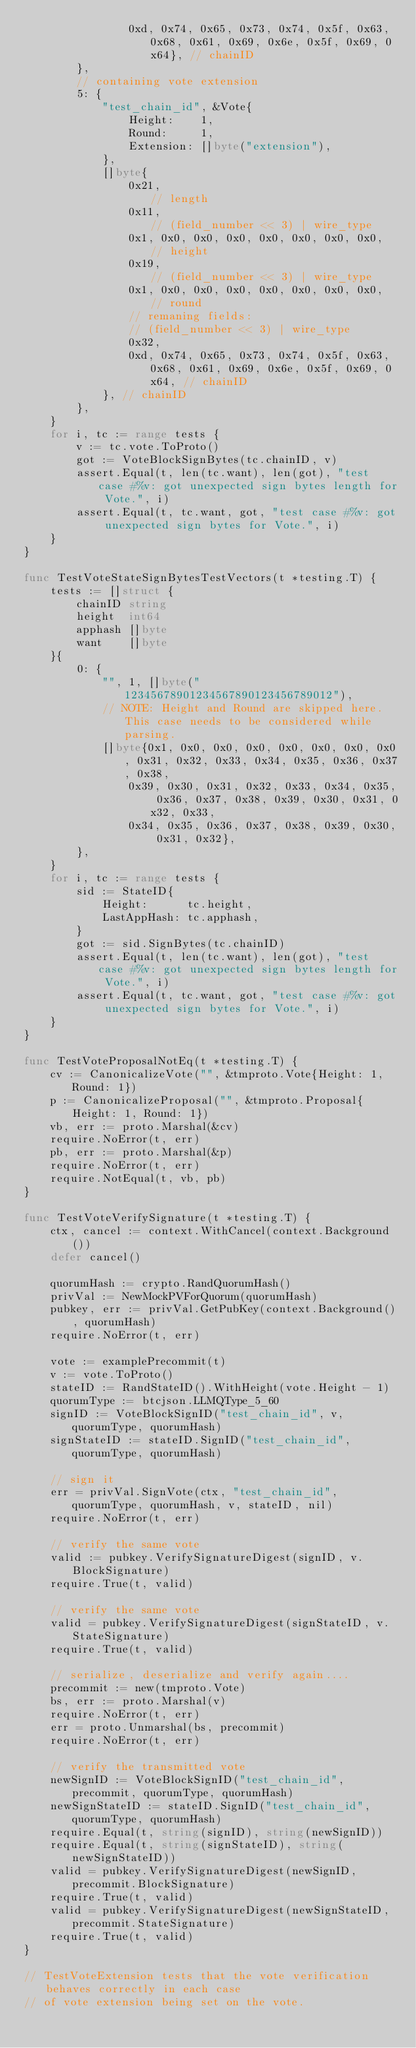<code> <loc_0><loc_0><loc_500><loc_500><_Go_>				0xd, 0x74, 0x65, 0x73, 0x74, 0x5f, 0x63, 0x68, 0x61, 0x69, 0x6e, 0x5f, 0x69, 0x64}, // chainID
		},
		// containing vote extension
		5: {
			"test_chain_id", &Vote{
				Height:    1,
				Round:     1,
				Extension: []byte("extension"),
			},
			[]byte{
				0x21,                                   // length
				0x11,                                   // (field_number << 3) | wire_type
				0x1, 0x0, 0x0, 0x0, 0x0, 0x0, 0x0, 0x0, // height
				0x19,                                   // (field_number << 3) | wire_type
				0x1, 0x0, 0x0, 0x0, 0x0, 0x0, 0x0, 0x0, // round
				// remaning fields:
				// (field_number << 3) | wire_type
				0x32,
				0xd, 0x74, 0x65, 0x73, 0x74, 0x5f, 0x63, 0x68, 0x61, 0x69, 0x6e, 0x5f, 0x69, 0x64, // chainID
			}, // chainID
		},
	}
	for i, tc := range tests {
		v := tc.vote.ToProto()
		got := VoteBlockSignBytes(tc.chainID, v)
		assert.Equal(t, len(tc.want), len(got), "test case #%v: got unexpected sign bytes length for Vote.", i)
		assert.Equal(t, tc.want, got, "test case #%v: got unexpected sign bytes for Vote.", i)
	}
}

func TestVoteStateSignBytesTestVectors(t *testing.T) {
	tests := []struct {
		chainID string
		height  int64
		apphash []byte
		want    []byte
	}{
		0: {
			"", 1, []byte("12345678901234567890123456789012"),
			// NOTE: Height and Round are skipped here. This case needs to be considered while parsing.
			[]byte{0x1, 0x0, 0x0, 0x0, 0x0, 0x0, 0x0, 0x0, 0x31, 0x32, 0x33, 0x34, 0x35, 0x36, 0x37, 0x38,
				0x39, 0x30, 0x31, 0x32, 0x33, 0x34, 0x35, 0x36, 0x37, 0x38, 0x39, 0x30, 0x31, 0x32, 0x33,
				0x34, 0x35, 0x36, 0x37, 0x38, 0x39, 0x30, 0x31, 0x32},
		},
	}
	for i, tc := range tests {
		sid := StateID{
			Height:      tc.height,
			LastAppHash: tc.apphash,
		}
		got := sid.SignBytes(tc.chainID)
		assert.Equal(t, len(tc.want), len(got), "test case #%v: got unexpected sign bytes length for Vote.", i)
		assert.Equal(t, tc.want, got, "test case #%v: got unexpected sign bytes for Vote.", i)
	}
}

func TestVoteProposalNotEq(t *testing.T) {
	cv := CanonicalizeVote("", &tmproto.Vote{Height: 1, Round: 1})
	p := CanonicalizeProposal("", &tmproto.Proposal{Height: 1, Round: 1})
	vb, err := proto.Marshal(&cv)
	require.NoError(t, err)
	pb, err := proto.Marshal(&p)
	require.NoError(t, err)
	require.NotEqual(t, vb, pb)
}

func TestVoteVerifySignature(t *testing.T) {
	ctx, cancel := context.WithCancel(context.Background())
	defer cancel()

	quorumHash := crypto.RandQuorumHash()
	privVal := NewMockPVForQuorum(quorumHash)
	pubkey, err := privVal.GetPubKey(context.Background(), quorumHash)
	require.NoError(t, err)

	vote := examplePrecommit(t)
	v := vote.ToProto()
	stateID := RandStateID().WithHeight(vote.Height - 1)
	quorumType := btcjson.LLMQType_5_60
	signID := VoteBlockSignID("test_chain_id", v, quorumType, quorumHash)
	signStateID := stateID.SignID("test_chain_id", quorumType, quorumHash)

	// sign it
	err = privVal.SignVote(ctx, "test_chain_id", quorumType, quorumHash, v, stateID, nil)
	require.NoError(t, err)

	// verify the same vote
	valid := pubkey.VerifySignatureDigest(signID, v.BlockSignature)
	require.True(t, valid)

	// verify the same vote
	valid = pubkey.VerifySignatureDigest(signStateID, v.StateSignature)
	require.True(t, valid)

	// serialize, deserialize and verify again....
	precommit := new(tmproto.Vote)
	bs, err := proto.Marshal(v)
	require.NoError(t, err)
	err = proto.Unmarshal(bs, precommit)
	require.NoError(t, err)

	// verify the transmitted vote
	newSignID := VoteBlockSignID("test_chain_id", precommit, quorumType, quorumHash)
	newSignStateID := stateID.SignID("test_chain_id", quorumType, quorumHash)
	require.Equal(t, string(signID), string(newSignID))
	require.Equal(t, string(signStateID), string(newSignStateID))
	valid = pubkey.VerifySignatureDigest(newSignID, precommit.BlockSignature)
	require.True(t, valid)
	valid = pubkey.VerifySignatureDigest(newSignStateID, precommit.StateSignature)
	require.True(t, valid)
}

// TestVoteExtension tests that the vote verification behaves correctly in each case
// of vote extension being set on the vote.</code> 